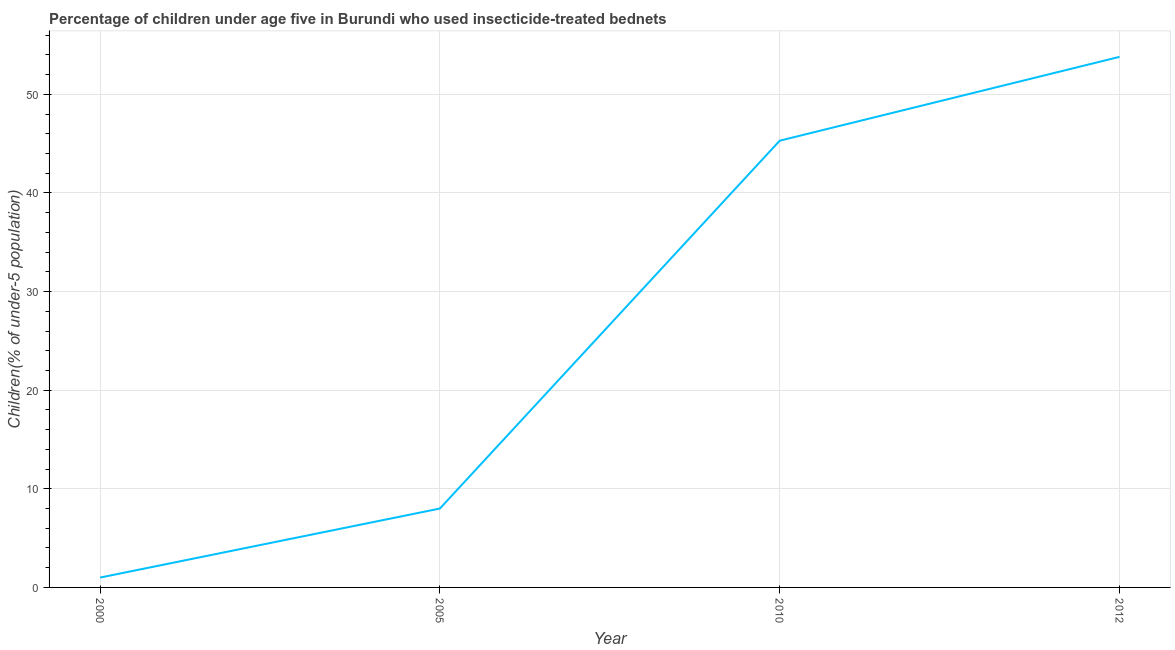What is the percentage of children who use of insecticide-treated bed nets in 2010?
Your answer should be very brief. 45.3. Across all years, what is the maximum percentage of children who use of insecticide-treated bed nets?
Keep it short and to the point. 53.8. Across all years, what is the minimum percentage of children who use of insecticide-treated bed nets?
Your answer should be compact. 1. In which year was the percentage of children who use of insecticide-treated bed nets minimum?
Keep it short and to the point. 2000. What is the sum of the percentage of children who use of insecticide-treated bed nets?
Give a very brief answer. 108.1. What is the difference between the percentage of children who use of insecticide-treated bed nets in 2000 and 2010?
Give a very brief answer. -44.3. What is the average percentage of children who use of insecticide-treated bed nets per year?
Keep it short and to the point. 27.02. What is the median percentage of children who use of insecticide-treated bed nets?
Provide a short and direct response. 26.65. In how many years, is the percentage of children who use of insecticide-treated bed nets greater than 8 %?
Provide a short and direct response. 2. Do a majority of the years between 2010 and 2012 (inclusive) have percentage of children who use of insecticide-treated bed nets greater than 44 %?
Your response must be concise. Yes. What is the ratio of the percentage of children who use of insecticide-treated bed nets in 2000 to that in 2005?
Your answer should be compact. 0.12. Is the percentage of children who use of insecticide-treated bed nets in 2000 less than that in 2012?
Make the answer very short. Yes. Is the difference between the percentage of children who use of insecticide-treated bed nets in 2000 and 2005 greater than the difference between any two years?
Make the answer very short. No. What is the difference between the highest and the second highest percentage of children who use of insecticide-treated bed nets?
Keep it short and to the point. 8.5. Is the sum of the percentage of children who use of insecticide-treated bed nets in 2000 and 2012 greater than the maximum percentage of children who use of insecticide-treated bed nets across all years?
Offer a very short reply. Yes. What is the difference between the highest and the lowest percentage of children who use of insecticide-treated bed nets?
Provide a succinct answer. 52.8. How many lines are there?
Provide a succinct answer. 1. How many years are there in the graph?
Offer a very short reply. 4. What is the difference between two consecutive major ticks on the Y-axis?
Offer a very short reply. 10. Does the graph contain any zero values?
Your response must be concise. No. Does the graph contain grids?
Provide a succinct answer. Yes. What is the title of the graph?
Offer a terse response. Percentage of children under age five in Burundi who used insecticide-treated bednets. What is the label or title of the Y-axis?
Offer a very short reply. Children(% of under-5 population). What is the Children(% of under-5 population) in 2000?
Provide a succinct answer. 1. What is the Children(% of under-5 population) in 2010?
Offer a very short reply. 45.3. What is the Children(% of under-5 population) of 2012?
Keep it short and to the point. 53.8. What is the difference between the Children(% of under-5 population) in 2000 and 2010?
Your answer should be very brief. -44.3. What is the difference between the Children(% of under-5 population) in 2000 and 2012?
Give a very brief answer. -52.8. What is the difference between the Children(% of under-5 population) in 2005 and 2010?
Your answer should be very brief. -37.3. What is the difference between the Children(% of under-5 population) in 2005 and 2012?
Provide a succinct answer. -45.8. What is the ratio of the Children(% of under-5 population) in 2000 to that in 2005?
Ensure brevity in your answer.  0.12. What is the ratio of the Children(% of under-5 population) in 2000 to that in 2010?
Your answer should be compact. 0.02. What is the ratio of the Children(% of under-5 population) in 2000 to that in 2012?
Ensure brevity in your answer.  0.02. What is the ratio of the Children(% of under-5 population) in 2005 to that in 2010?
Make the answer very short. 0.18. What is the ratio of the Children(% of under-5 population) in 2005 to that in 2012?
Your answer should be very brief. 0.15. What is the ratio of the Children(% of under-5 population) in 2010 to that in 2012?
Your response must be concise. 0.84. 